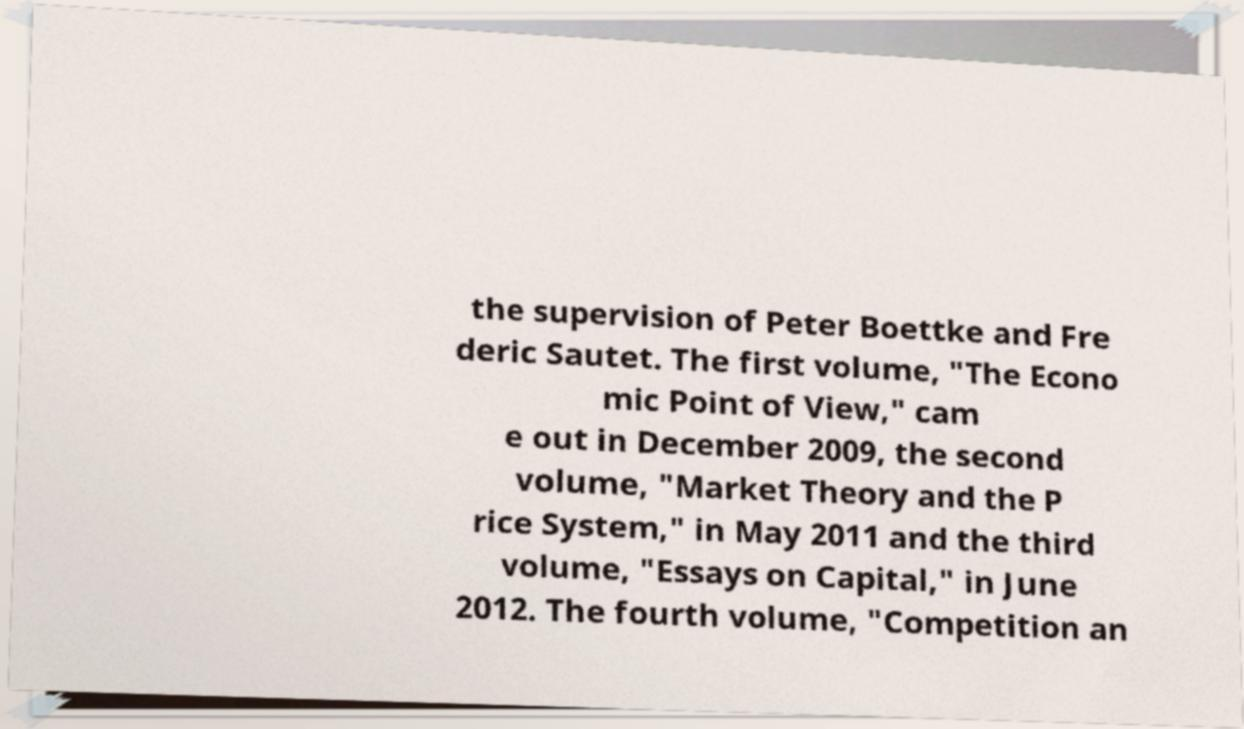Please identify and transcribe the text found in this image. the supervision of Peter Boettke and Fre deric Sautet. The first volume, "The Econo mic Point of View," cam e out in December 2009, the second volume, "Market Theory and the P rice System," in May 2011 and the third volume, "Essays on Capital," in June 2012. The fourth volume, "Competition an 